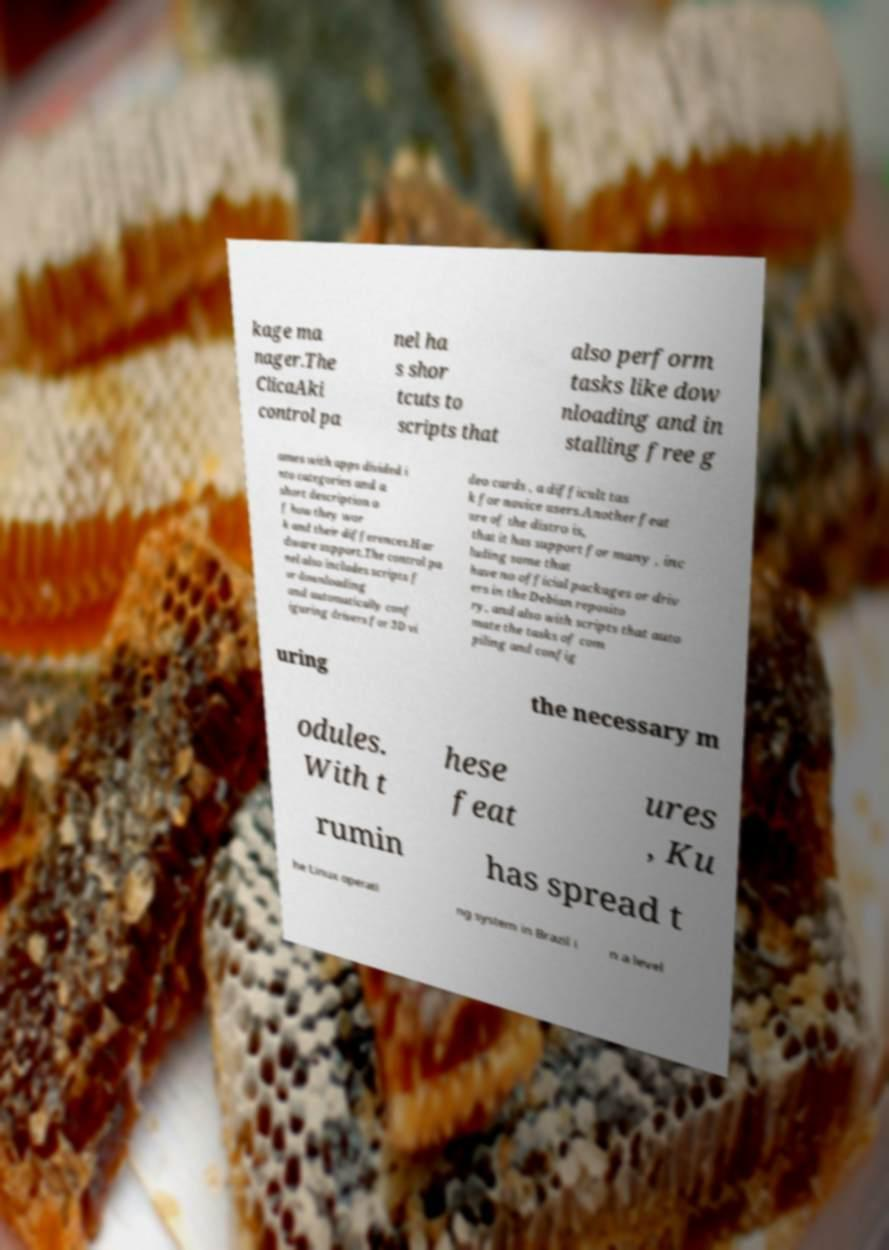Can you accurately transcribe the text from the provided image for me? kage ma nager.The ClicaAki control pa nel ha s shor tcuts to scripts that also perform tasks like dow nloading and in stalling free g ames with apps divided i nto categories and a short description o f how they wor k and their differences.Har dware support.The control pa nel also includes scripts f or downloading and automatically conf iguring drivers for 3D vi deo cards , a difficult tas k for novice users.Another feat ure of the distro is, that it has support for many , inc luding some that have no official packages or driv ers in the Debian reposito ry, and also with scripts that auto mate the tasks of com piling and config uring the necessary m odules. With t hese feat ures , Ku rumin has spread t he Linux operati ng system in Brazil i n a level 